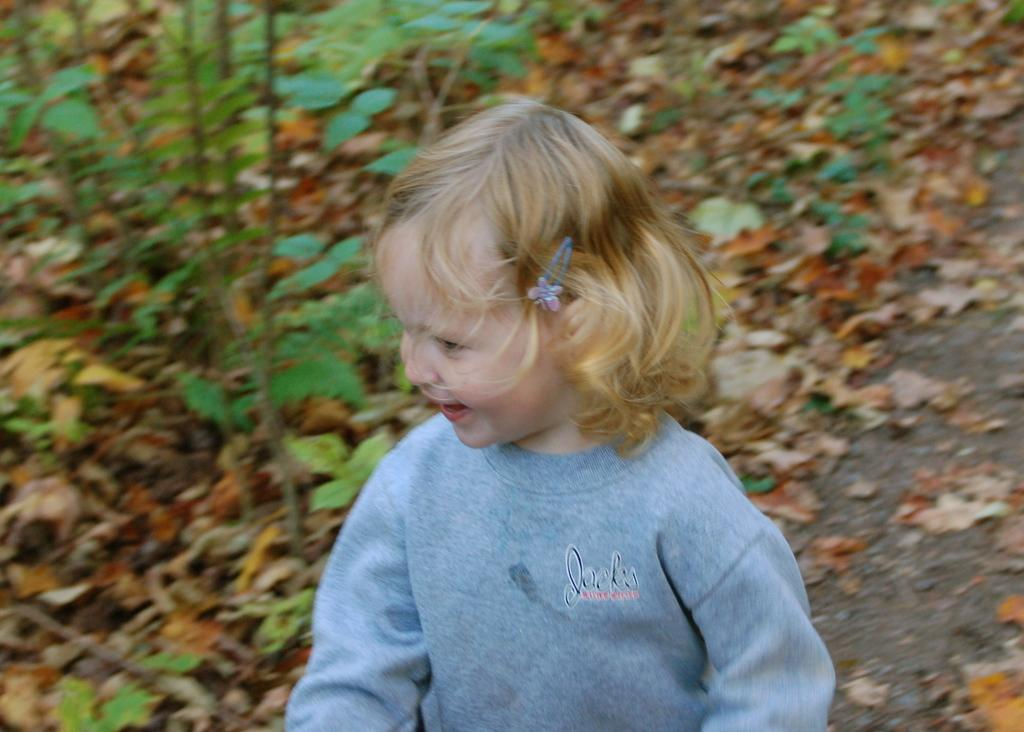What is the main subject of the image? There is a child in the image. What is the child doing in the image? The child is smiling in the image. What is the child wearing in the image? The child is wearing a blue dress in the image. What can be seen in the background of the image? There are trees visible in the background of the image. What colors can be observed on the leaves of the trees? The leaves on the trees have brown, yellow, and green colors. What type of lock is holding the child's dress in the image? There is no lock present in the image; the child is wearing a blue dress without any locks. 